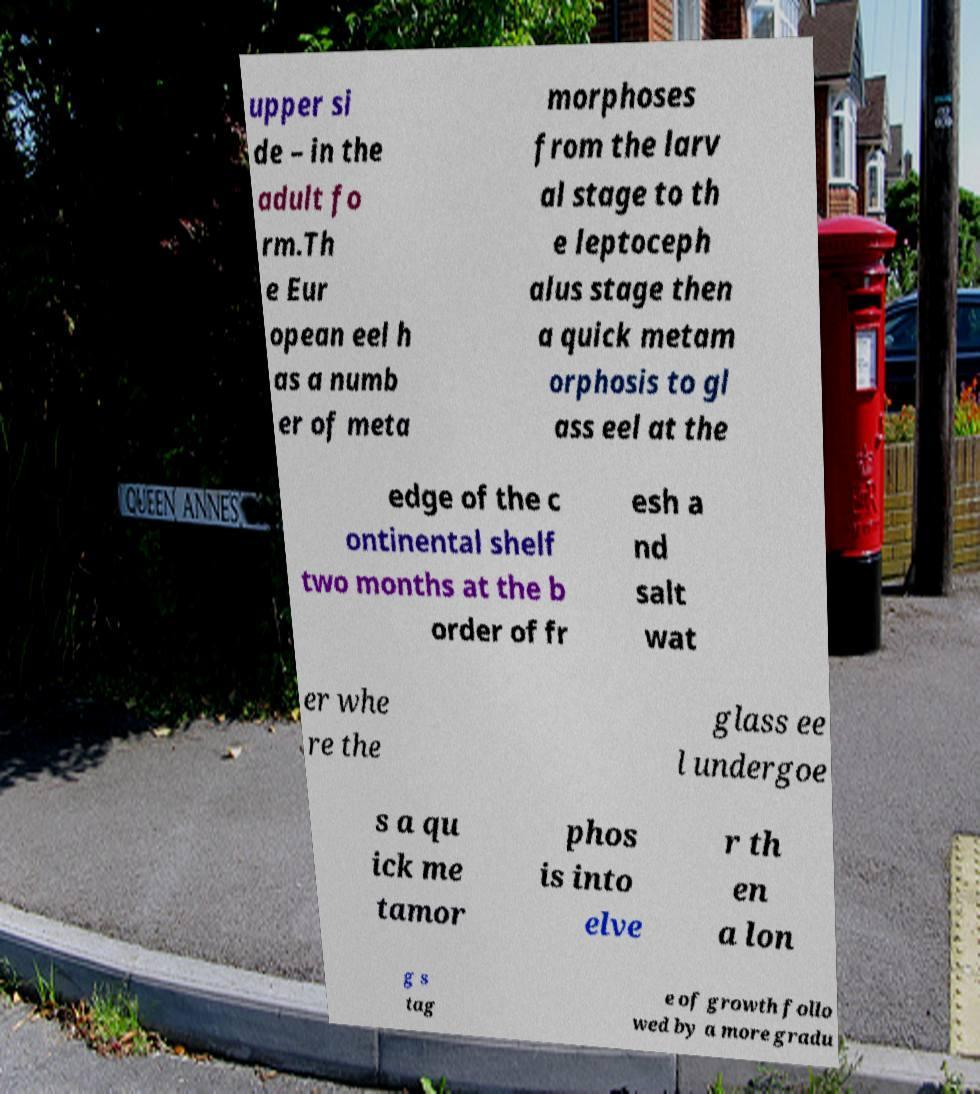What messages or text are displayed in this image? I need them in a readable, typed format. upper si de – in the adult fo rm.Th e Eur opean eel h as a numb er of meta morphoses from the larv al stage to th e leptoceph alus stage then a quick metam orphosis to gl ass eel at the edge of the c ontinental shelf two months at the b order of fr esh a nd salt wat er whe re the glass ee l undergoe s a qu ick me tamor phos is into elve r th en a lon g s tag e of growth follo wed by a more gradu 